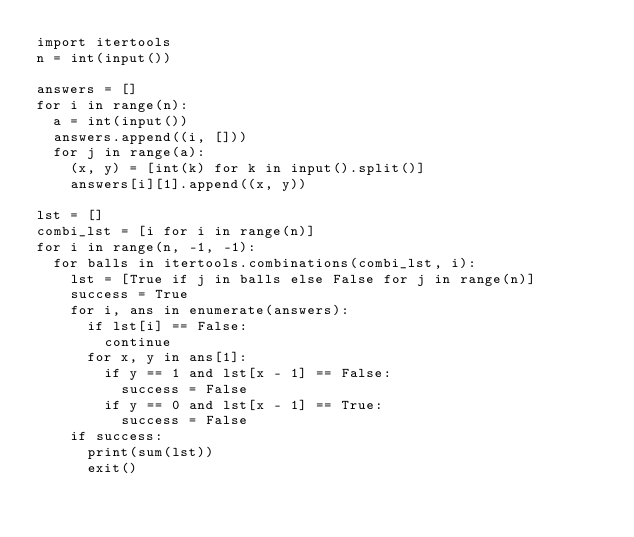<code> <loc_0><loc_0><loc_500><loc_500><_Python_>import itertools
n = int(input())

answers = []
for i in range(n):
	a = int(input())
	answers.append((i, []))
	for j in range(a):
		(x, y) = [int(k) for k in input().split()]
		answers[i][1].append((x, y))

lst = []
combi_lst = [i for i in range(n)]
for i in range(n, -1, -1):
	for balls in itertools.combinations(combi_lst, i):
		lst = [True if j in balls else False for j in range(n)]
		success = True
		for i, ans in enumerate(answers):
			if lst[i] == False:
				continue
			for x, y in ans[1]:
				if y == 1 and lst[x - 1] == False:
					success = False
				if y == 0 and lst[x - 1] == True:
					success = False
		if success:
			print(sum(lst))
			exit()</code> 